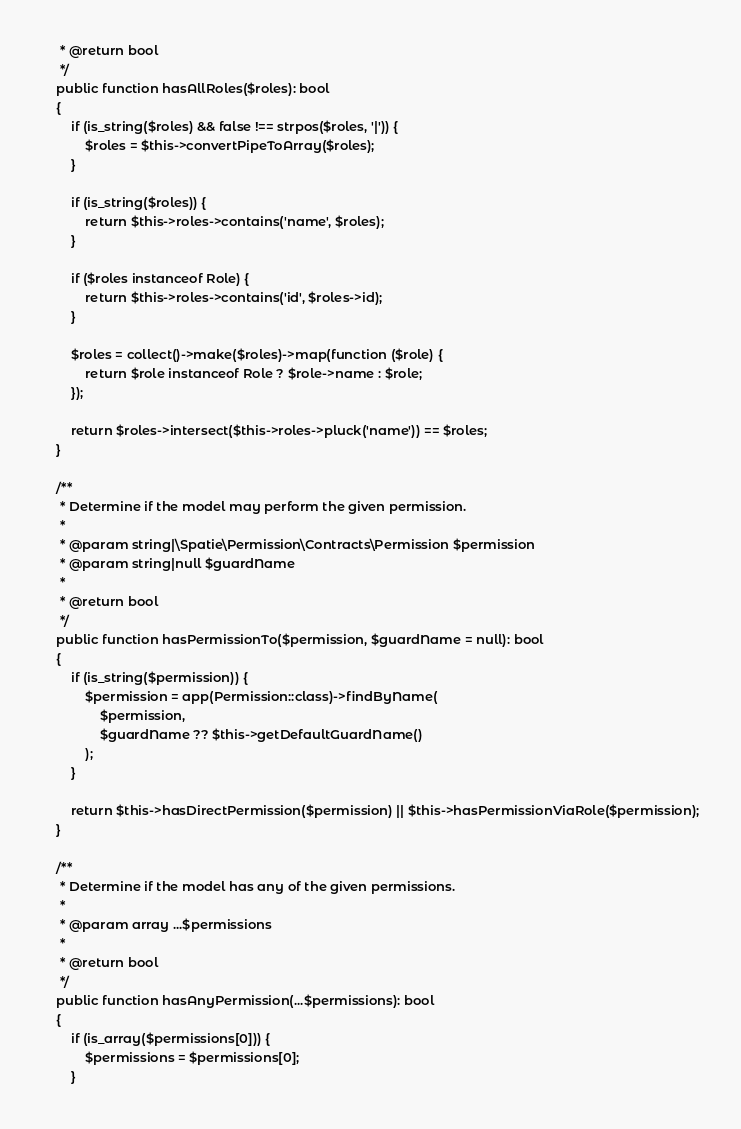Convert code to text. <code><loc_0><loc_0><loc_500><loc_500><_PHP_>     * @return bool
     */
    public function hasAllRoles($roles): bool
    {
        if (is_string($roles) && false !== strpos($roles, '|')) {
            $roles = $this->convertPipeToArray($roles);
        }

        if (is_string($roles)) {
            return $this->roles->contains('name', $roles);
        }

        if ($roles instanceof Role) {
            return $this->roles->contains('id', $roles->id);
        }

        $roles = collect()->make($roles)->map(function ($role) {
            return $role instanceof Role ? $role->name : $role;
        });

        return $roles->intersect($this->roles->pluck('name')) == $roles;
    }

    /**
     * Determine if the model may perform the given permission.
     *
     * @param string|\Spatie\Permission\Contracts\Permission $permission
     * @param string|null $guardName
     *
     * @return bool
     */
    public function hasPermissionTo($permission, $guardName = null): bool
    {
        if (is_string($permission)) {
            $permission = app(Permission::class)->findByName(
                $permission,
                $guardName ?? $this->getDefaultGuardName()
            );
        }

        return $this->hasDirectPermission($permission) || $this->hasPermissionViaRole($permission);
    }

    /**
     * Determine if the model has any of the given permissions.
     *
     * @param array ...$permissions
     *
     * @return bool
     */
    public function hasAnyPermission(...$permissions): bool
    {
        if (is_array($permissions[0])) {
            $permissions = $permissions[0];
        }
</code> 